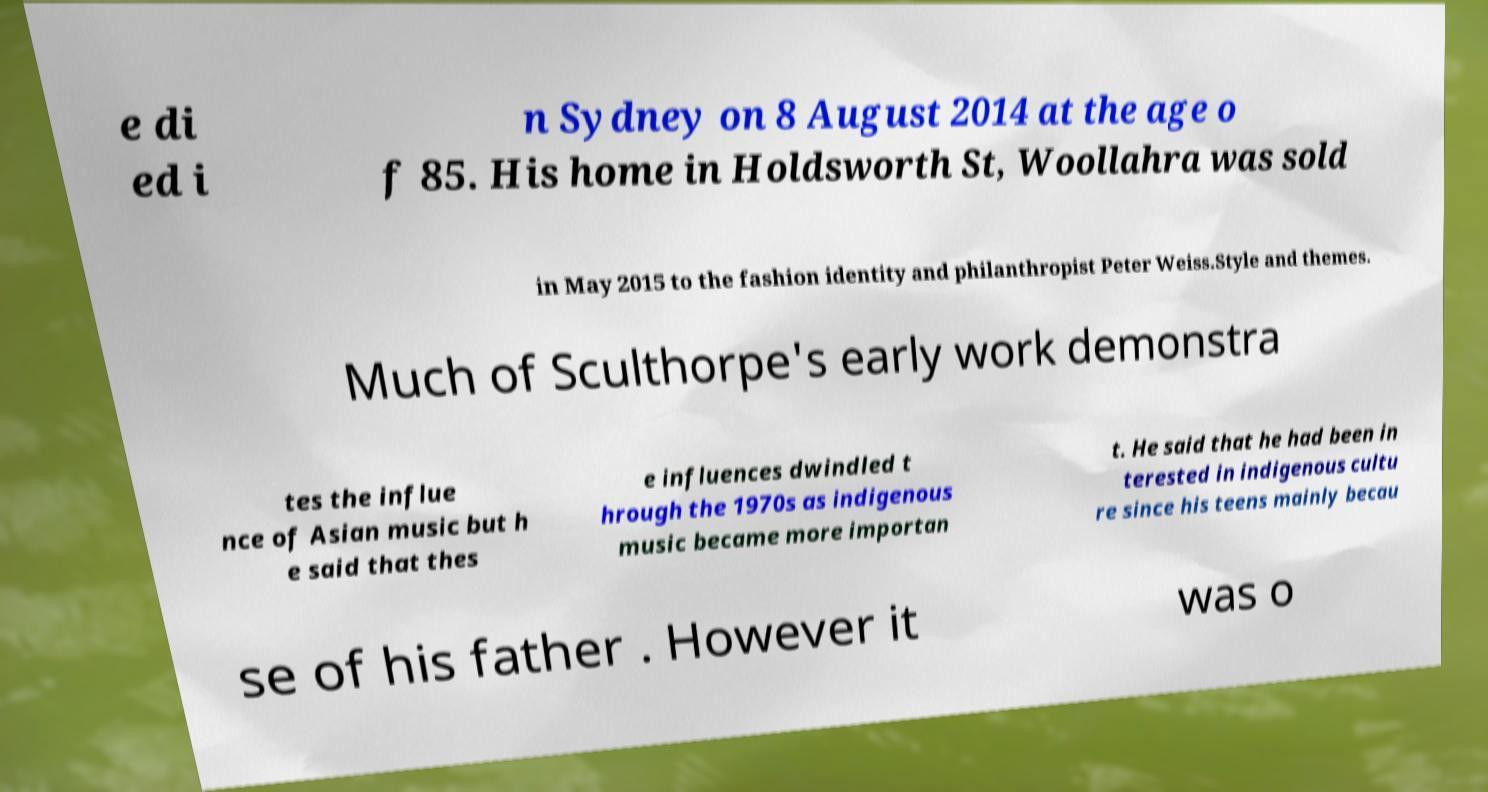Please read and relay the text visible in this image. What does it say? e di ed i n Sydney on 8 August 2014 at the age o f 85. His home in Holdsworth St, Woollahra was sold in May 2015 to the fashion identity and philanthropist Peter Weiss.Style and themes. Much of Sculthorpe's early work demonstra tes the influe nce of Asian music but h e said that thes e influences dwindled t hrough the 1970s as indigenous music became more importan t. He said that he had been in terested in indigenous cultu re since his teens mainly becau se of his father . However it was o 